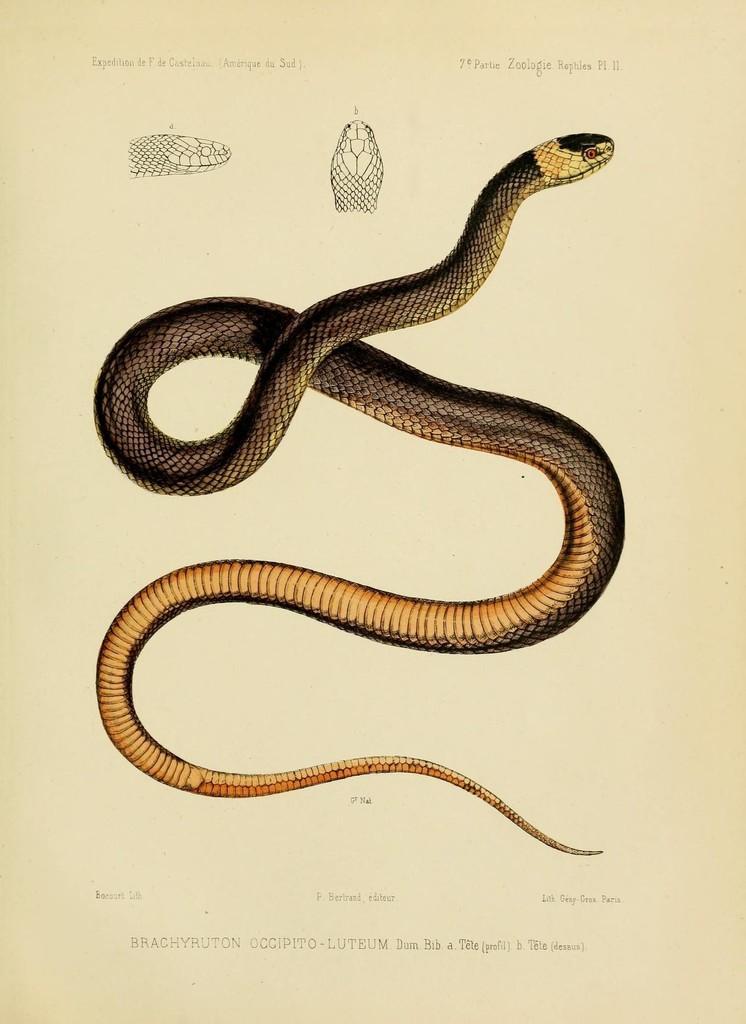In one or two sentences, can you explain what this image depicts? In the image we can see the diagram of the snake and this is a text. 